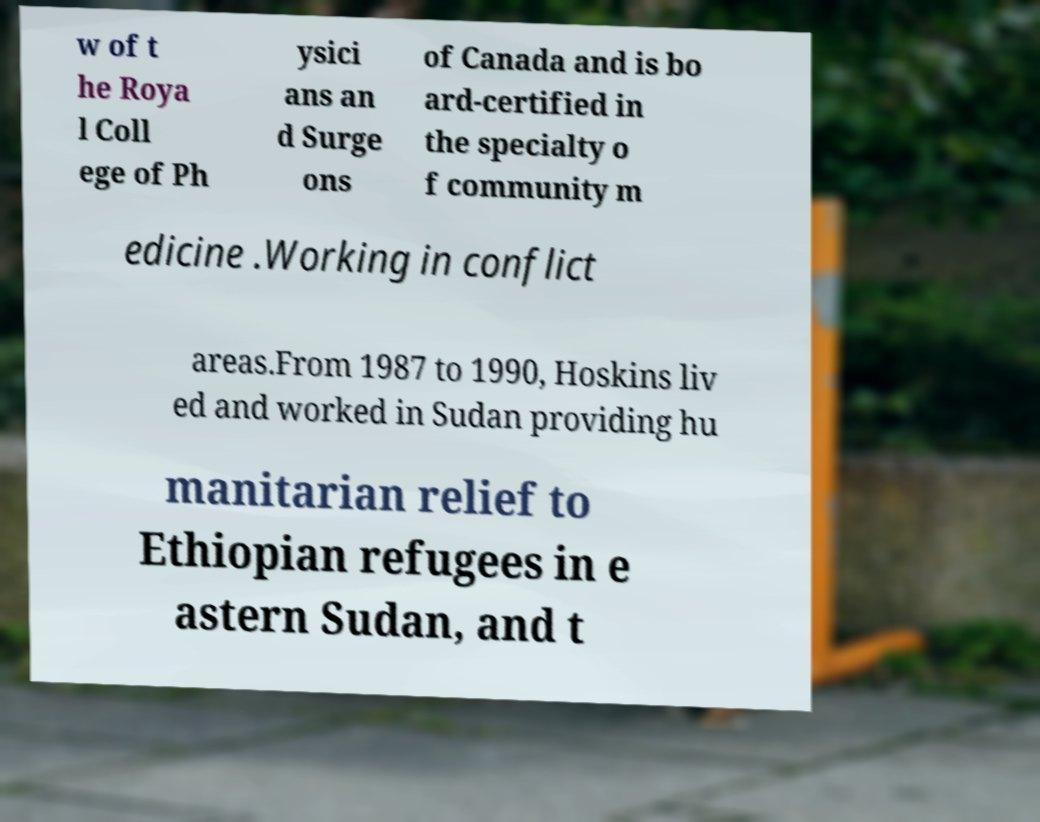Can you accurately transcribe the text from the provided image for me? w of t he Roya l Coll ege of Ph ysici ans an d Surge ons of Canada and is bo ard-certified in the specialty o f community m edicine .Working in conflict areas.From 1987 to 1990, Hoskins liv ed and worked in Sudan providing hu manitarian relief to Ethiopian refugees in e astern Sudan, and t 